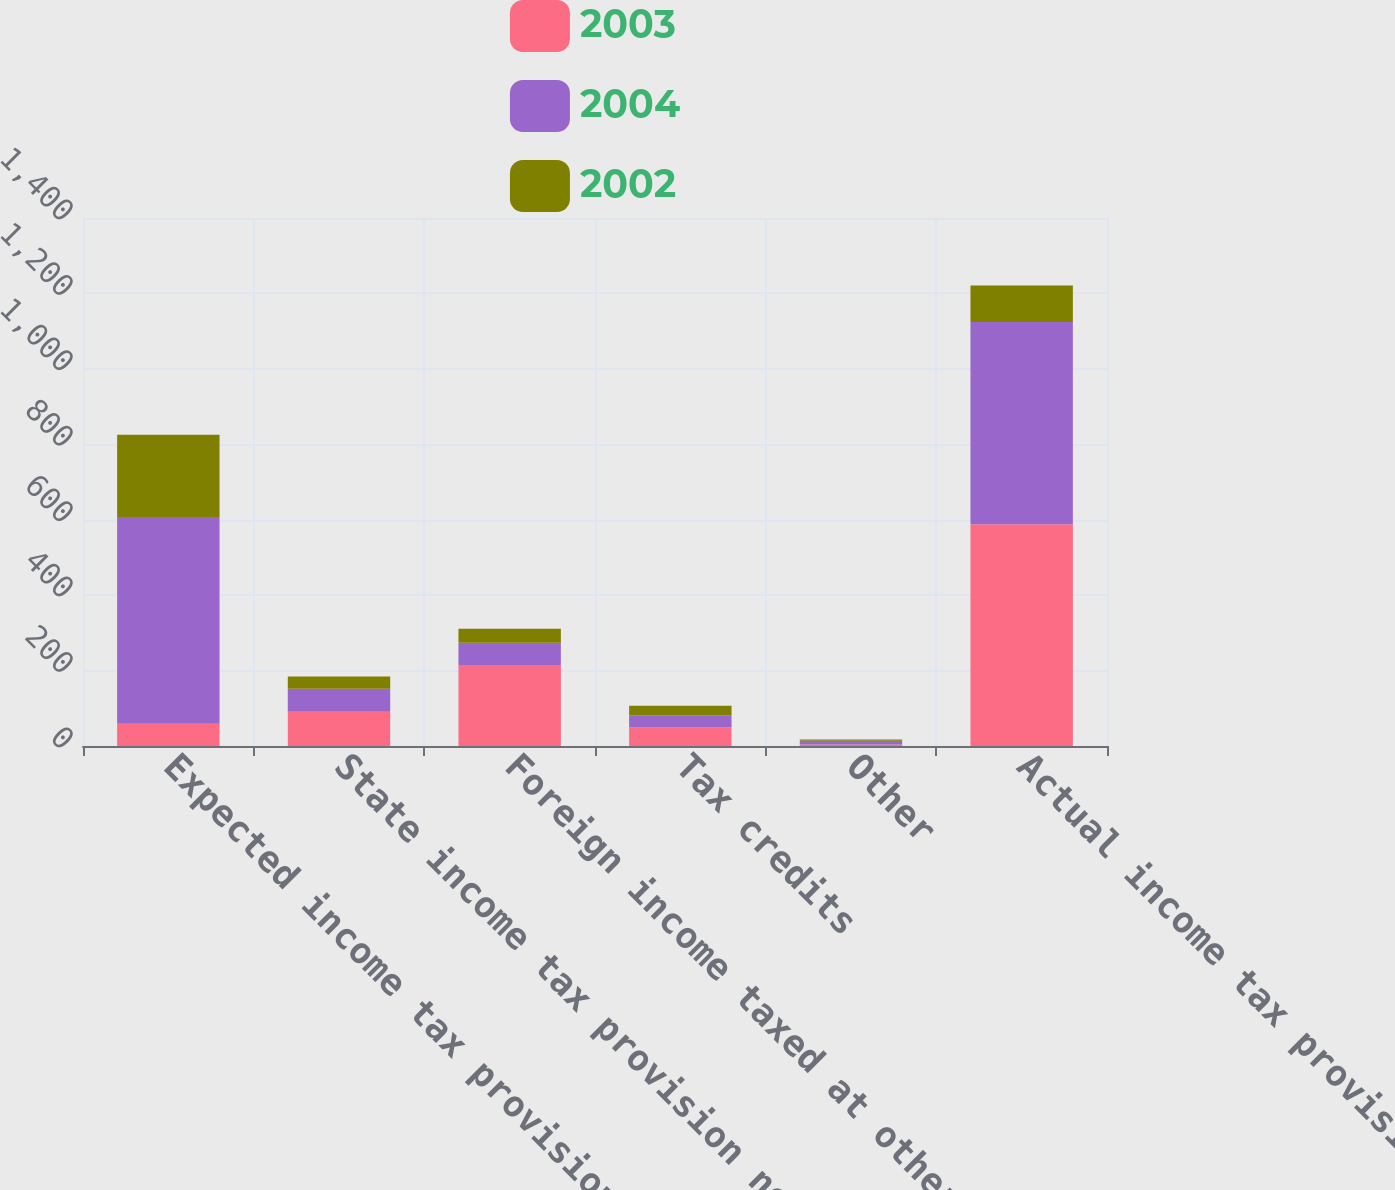Convert chart. <chart><loc_0><loc_0><loc_500><loc_500><stacked_bar_chart><ecel><fcel>Expected income tax provision<fcel>State income tax provision net<fcel>Foreign income taxed at other<fcel>Tax credits<fcel>Other<fcel>Actual income tax provision<nl><fcel>2003<fcel>59<fcel>91<fcel>215<fcel>49<fcel>4<fcel>588<nl><fcel>2004<fcel>548<fcel>61<fcel>59<fcel>32<fcel>10<fcel>536<nl><fcel>2002<fcel>218<fcel>32<fcel>37<fcel>26<fcel>3<fcel>97<nl></chart> 